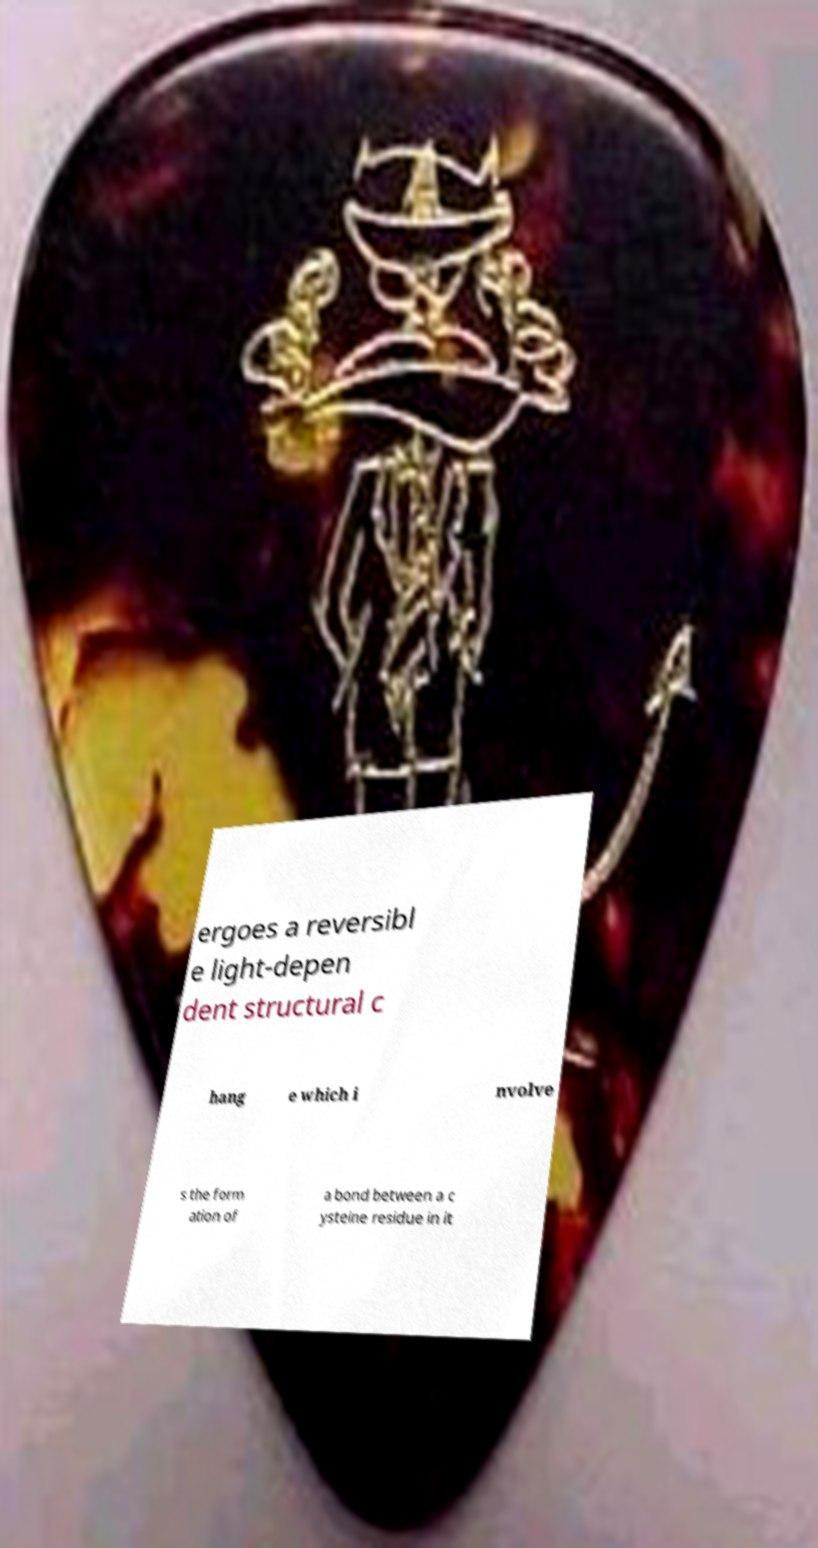What messages or text are displayed in this image? I need them in a readable, typed format. ergoes a reversibl e light-depen dent structural c hang e which i nvolve s the form ation of a bond between a c ysteine residue in it 